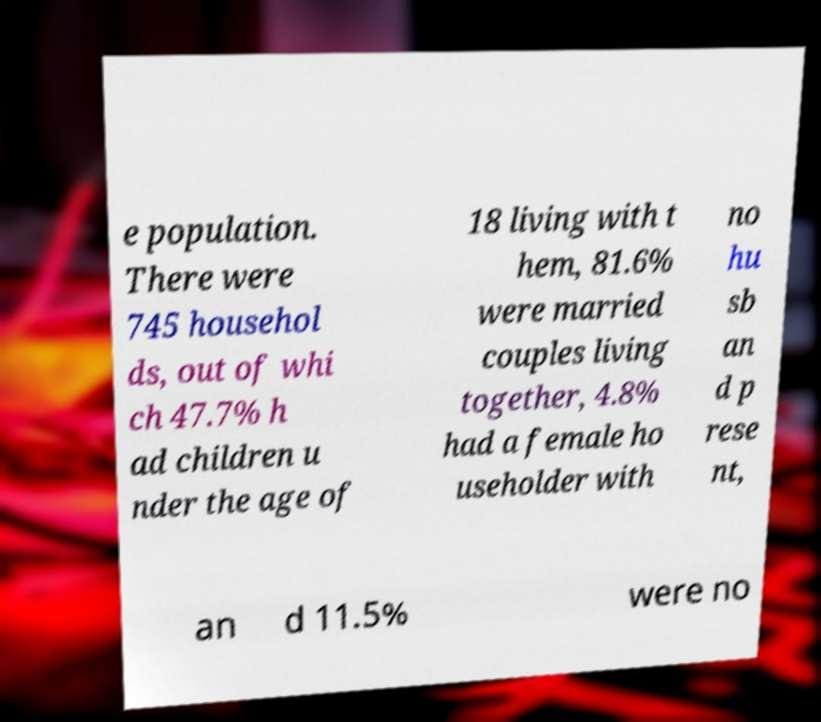For documentation purposes, I need the text within this image transcribed. Could you provide that? e population. There were 745 househol ds, out of whi ch 47.7% h ad children u nder the age of 18 living with t hem, 81.6% were married couples living together, 4.8% had a female ho useholder with no hu sb an d p rese nt, an d 11.5% were no 